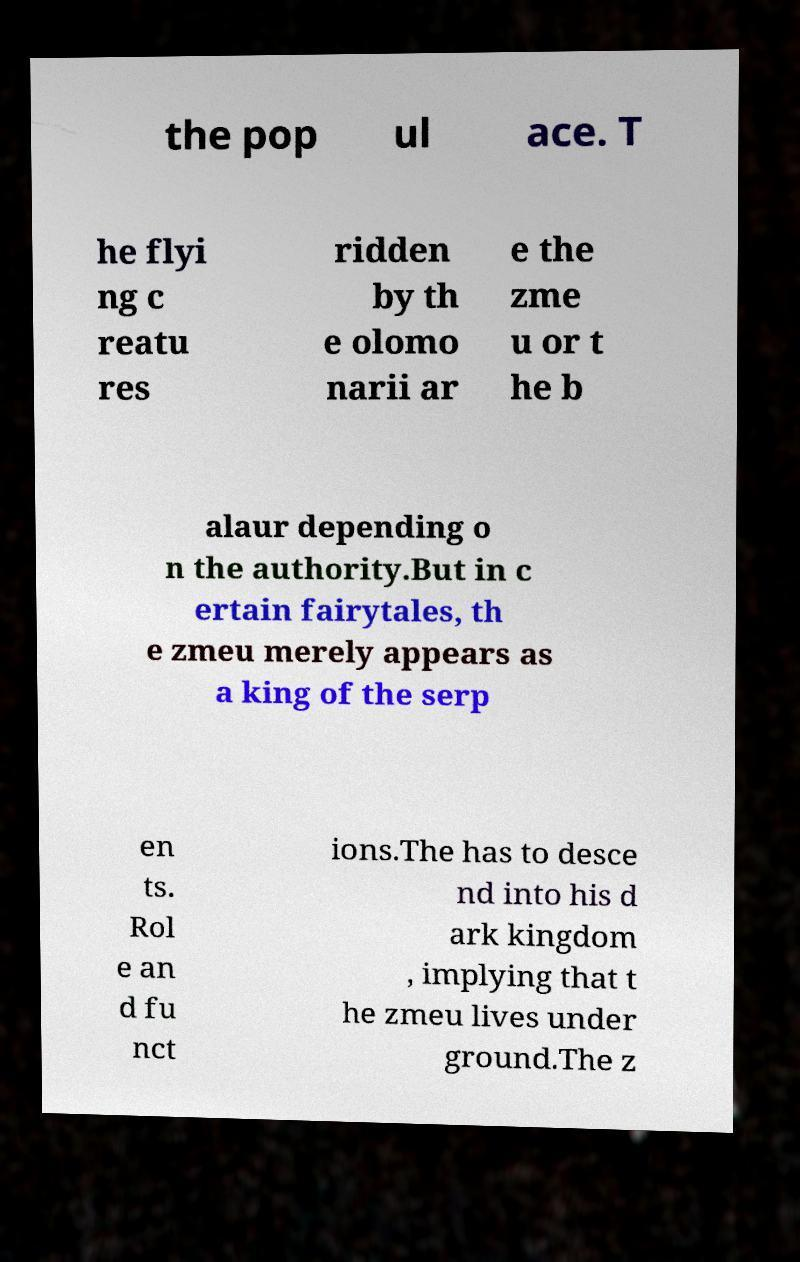Can you read and provide the text displayed in the image?This photo seems to have some interesting text. Can you extract and type it out for me? the pop ul ace. T he flyi ng c reatu res ridden by th e olomo narii ar e the zme u or t he b alaur depending o n the authority.But in c ertain fairytales, th e zmeu merely appears as a king of the serp en ts. Rol e an d fu nct ions.The has to desce nd into his d ark kingdom , implying that t he zmeu lives under ground.The z 